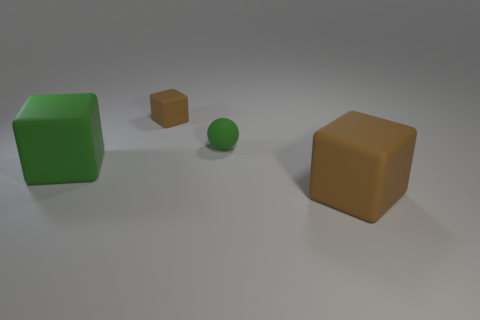Add 3 small brown blocks. How many objects exist? 7 Subtract all cubes. How many objects are left? 1 Add 4 large green matte things. How many large green matte things are left? 5 Add 2 big green matte cylinders. How many big green matte cylinders exist? 2 Subtract 0 gray cylinders. How many objects are left? 4 Subtract all cyan metal spheres. Subtract all spheres. How many objects are left? 3 